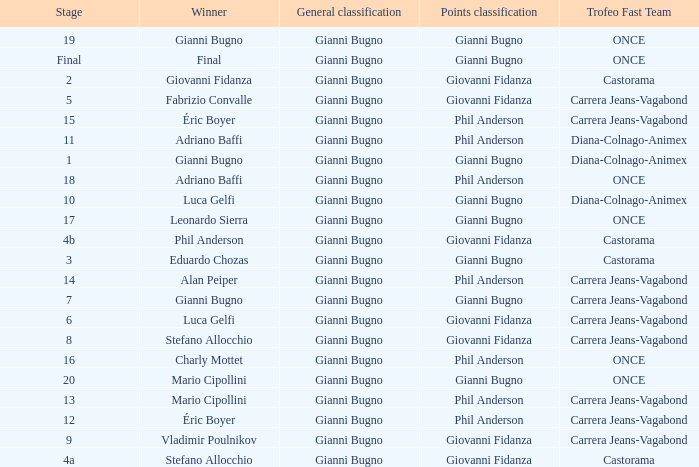Who is the points classification in stage 1? Gianni Bugno. 